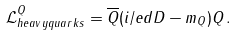Convert formula to latex. <formula><loc_0><loc_0><loc_500><loc_500>\mathcal { L } ^ { Q } _ { h e a v y q u a r k s } = \overline { Q } ( i \slash e d { D } - m _ { Q } ) Q \, .</formula> 